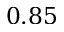<formula> <loc_0><loc_0><loc_500><loc_500>0 . 8 5</formula> 